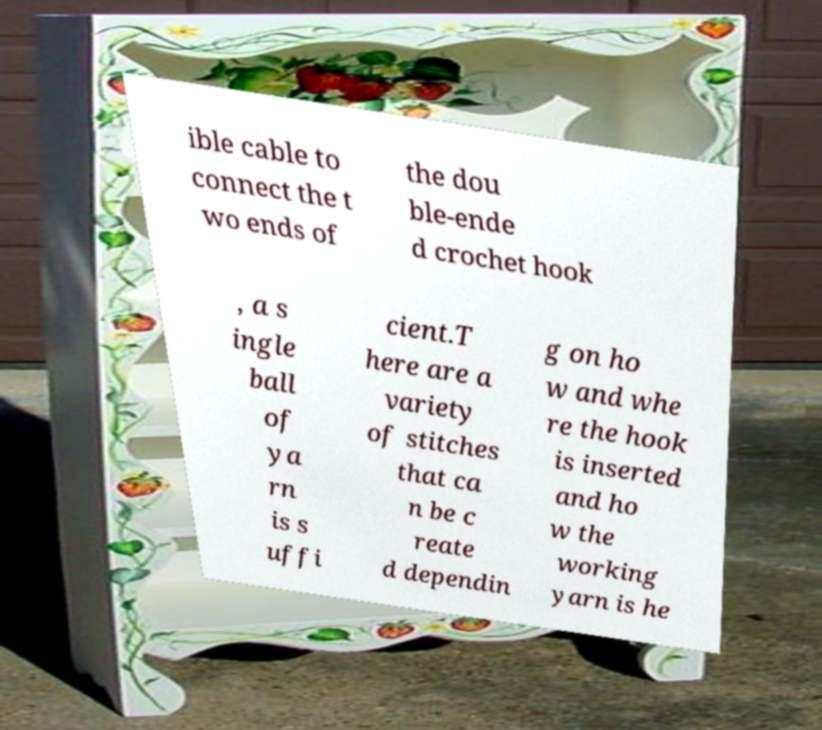There's text embedded in this image that I need extracted. Can you transcribe it verbatim? ible cable to connect the t wo ends of the dou ble-ende d crochet hook , a s ingle ball of ya rn is s uffi cient.T here are a variety of stitches that ca n be c reate d dependin g on ho w and whe re the hook is inserted and ho w the working yarn is he 